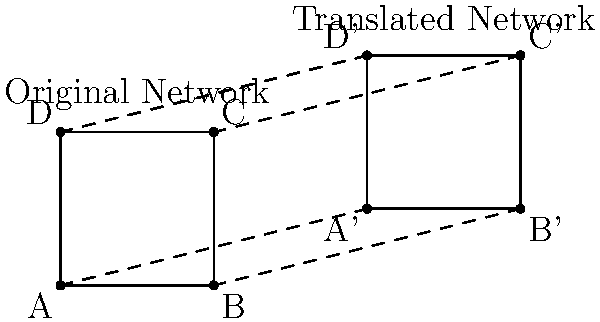In a manufacturing facility, an IoT network diagram needs to be translated to cover a larger production area. The original network forms a square with side length 2 units, and its bottom-left corner is at the origin (0,0). If the network needs to be translated 4 units to the right and 1 unit up to cover the new area, what are the coordinates of point C' (the top-right corner) in the translated network? To solve this problem, we'll follow these steps:

1. Identify the original coordinates of point C:
   Point C is at (2,2) in the original network.

2. Determine the translation vector:
   The network is translated 4 units right and 1 unit up.
   Translation vector: $\vec{v} = (4,1)$

3. Apply the translation to point C:
   To translate a point, we add the translation vector to its coordinates.
   $C' = C + \vec{v}$
   $C' = (2,2) + (4,1)$
   $C' = (2+4, 2+1)$
   $C' = (6,3)$

Therefore, the coordinates of point C' in the translated network are (6,3).
Answer: (6,3) 